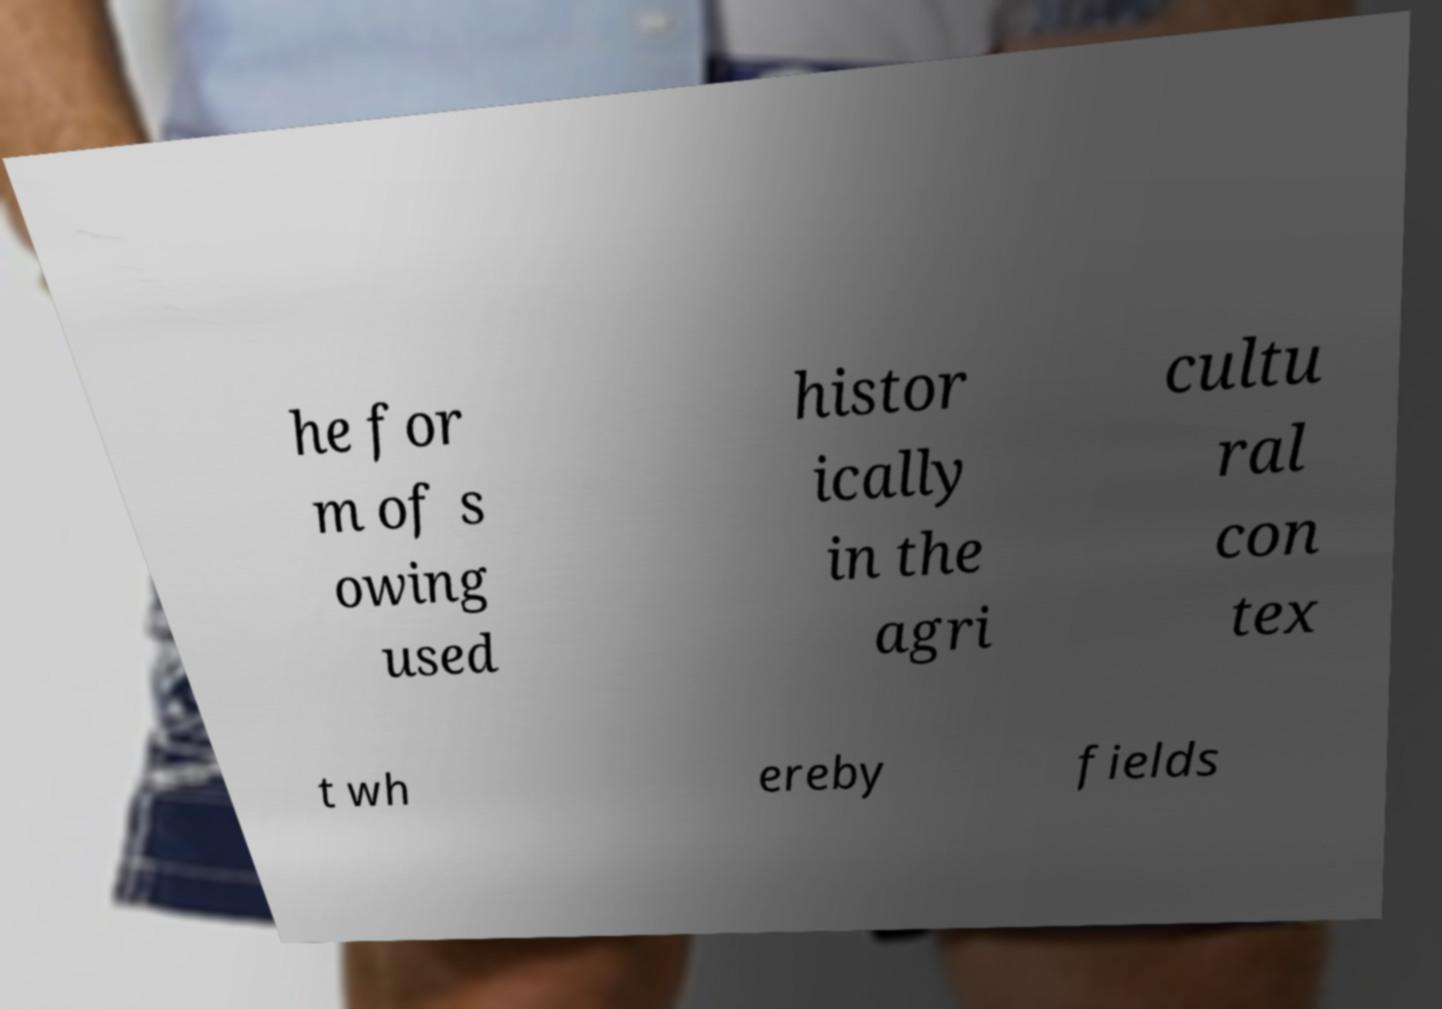What messages or text are displayed in this image? I need them in a readable, typed format. he for m of s owing used histor ically in the agri cultu ral con tex t wh ereby fields 